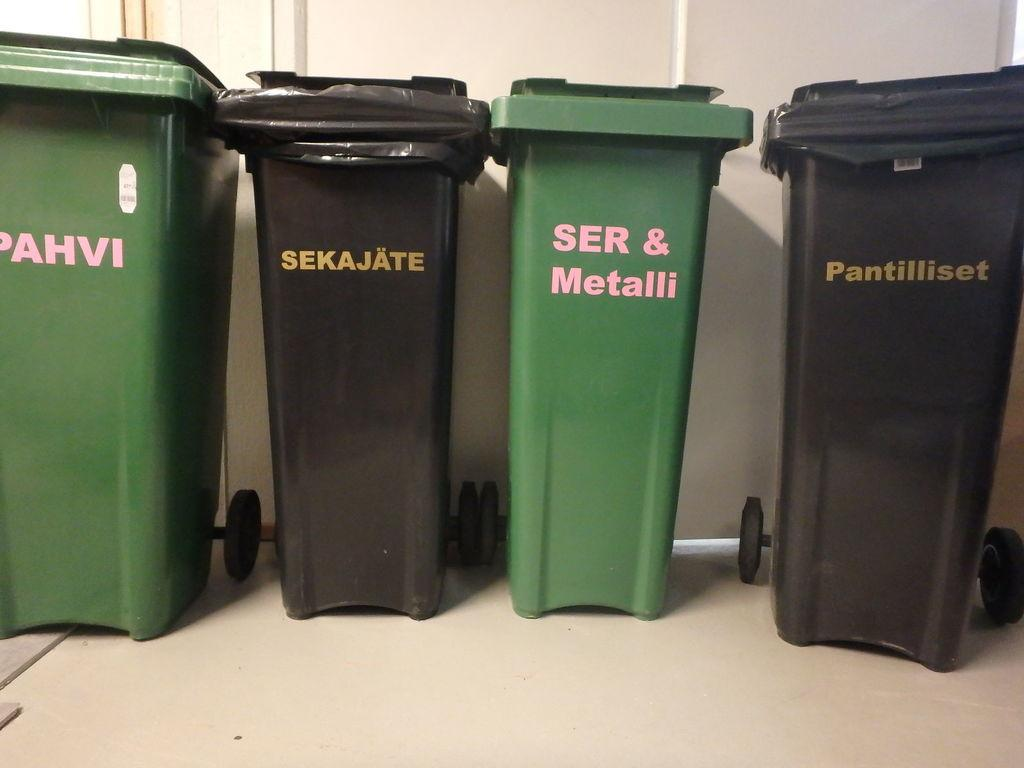<image>
Present a compact description of the photo's key features. Four trash cans with words like sekajate painted on them are lined up against a wall. 